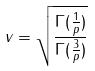Convert formula to latex. <formula><loc_0><loc_0><loc_500><loc_500>v = \sqrt { \frac { \Gamma ( \frac { 1 } { p } ) } { \Gamma ( \frac { 3 } { p } ) } }</formula> 